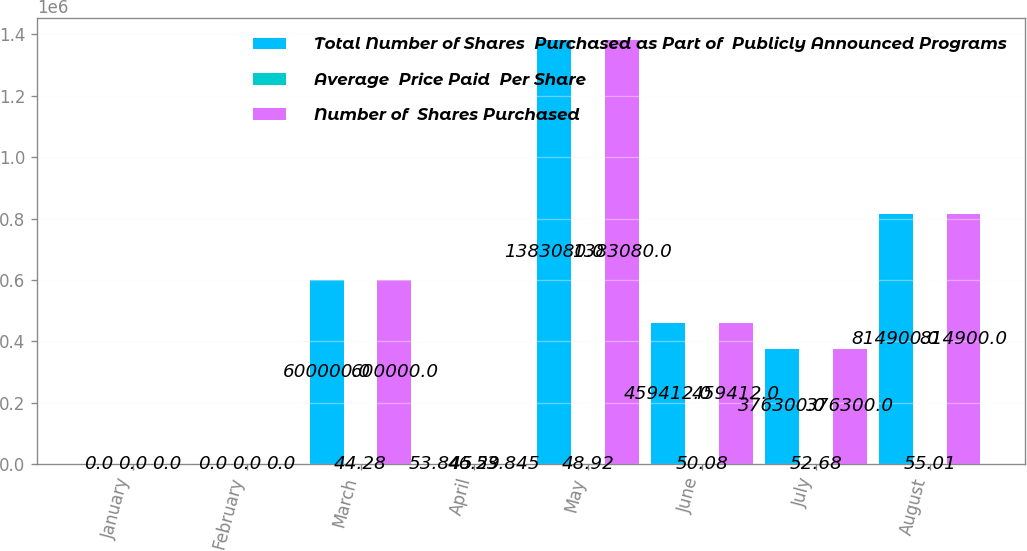Convert chart to OTSL. <chart><loc_0><loc_0><loc_500><loc_500><stacked_bar_chart><ecel><fcel>January<fcel>February<fcel>March<fcel>April<fcel>May<fcel>June<fcel>July<fcel>August<nl><fcel>Total Number of Shares  Purchased as Part of  Publicly Announced Programs<fcel>0<fcel>0<fcel>600000<fcel>53.845<fcel>1.38308e+06<fcel>459412<fcel>376300<fcel>814900<nl><fcel>Average  Price Paid  Per Share<fcel>0<fcel>0<fcel>44.28<fcel>46.29<fcel>48.92<fcel>50.08<fcel>52.68<fcel>55.01<nl><fcel>Number of  Shares Purchased<fcel>0<fcel>0<fcel>600000<fcel>53.845<fcel>1.38308e+06<fcel>459412<fcel>376300<fcel>814900<nl></chart> 